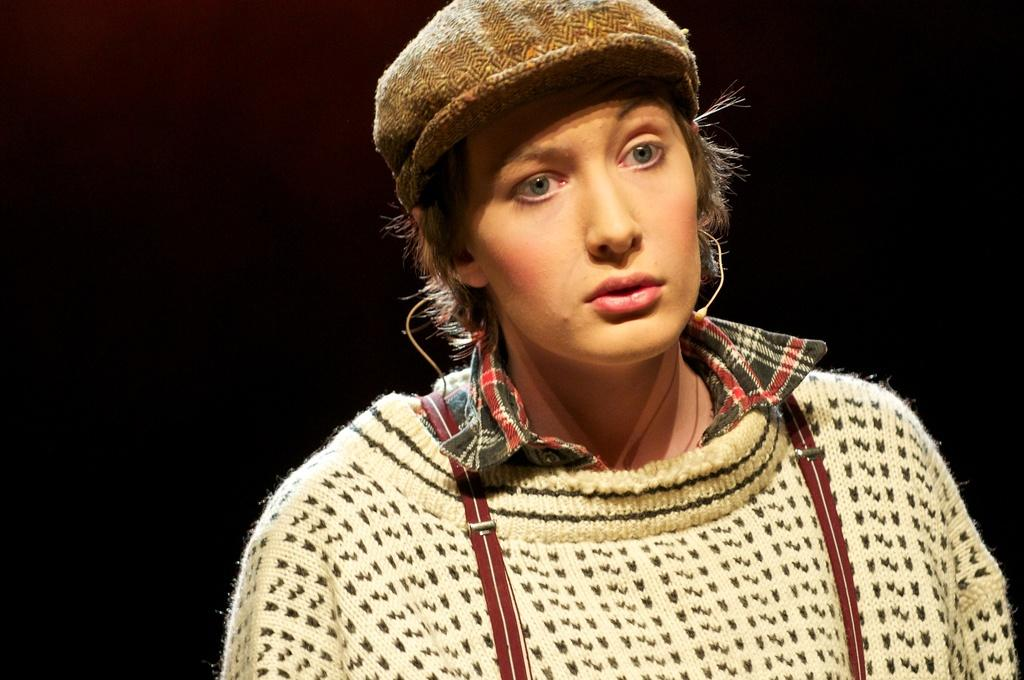What is the main subject of the image? There is a person in the image. What is the person in the image doing? The person is staring. Can you describe the person's attire in the image? The person is wearing a hat. Where is the harbor located in the image? There is no harbor present in the image. What type of advertisement can be seen in the image? There is no advertisement present in the image. 